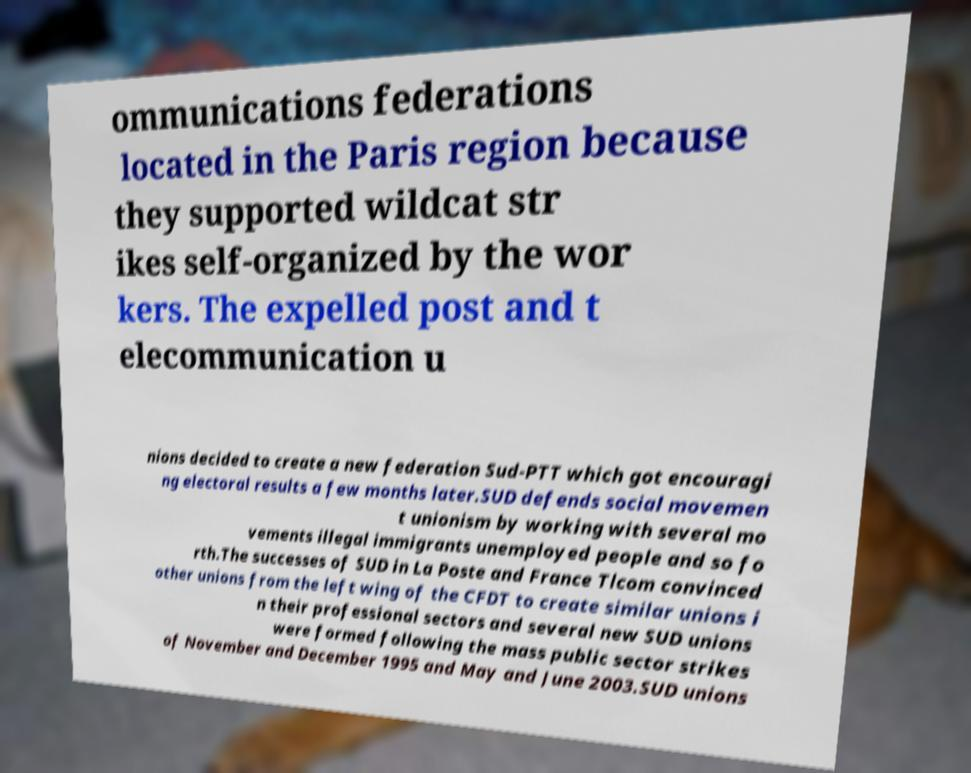Can you read and provide the text displayed in the image?This photo seems to have some interesting text. Can you extract and type it out for me? ommunications federations located in the Paris region because they supported wildcat str ikes self-organized by the wor kers. The expelled post and t elecommunication u nions decided to create a new federation Sud-PTT which got encouragi ng electoral results a few months later.SUD defends social movemen t unionism by working with several mo vements illegal immigrants unemployed people and so fo rth.The successes of SUD in La Poste and France Tlcom convinced other unions from the left wing of the CFDT to create similar unions i n their professional sectors and several new SUD unions were formed following the mass public sector strikes of November and December 1995 and May and June 2003.SUD unions 